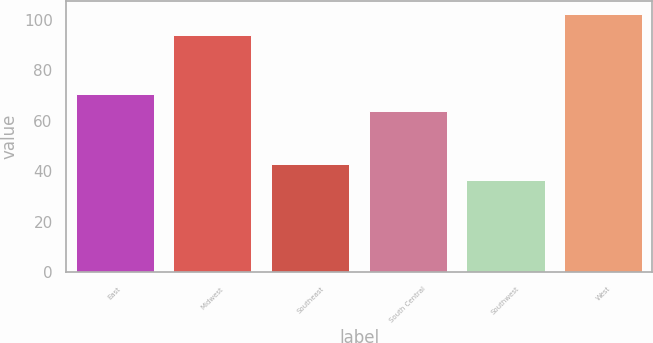Convert chart to OTSL. <chart><loc_0><loc_0><loc_500><loc_500><bar_chart><fcel>East<fcel>Midwest<fcel>Southeast<fcel>South Central<fcel>Southwest<fcel>West<nl><fcel>70.7<fcel>94.1<fcel>43.1<fcel>64.1<fcel>36.5<fcel>102.5<nl></chart> 